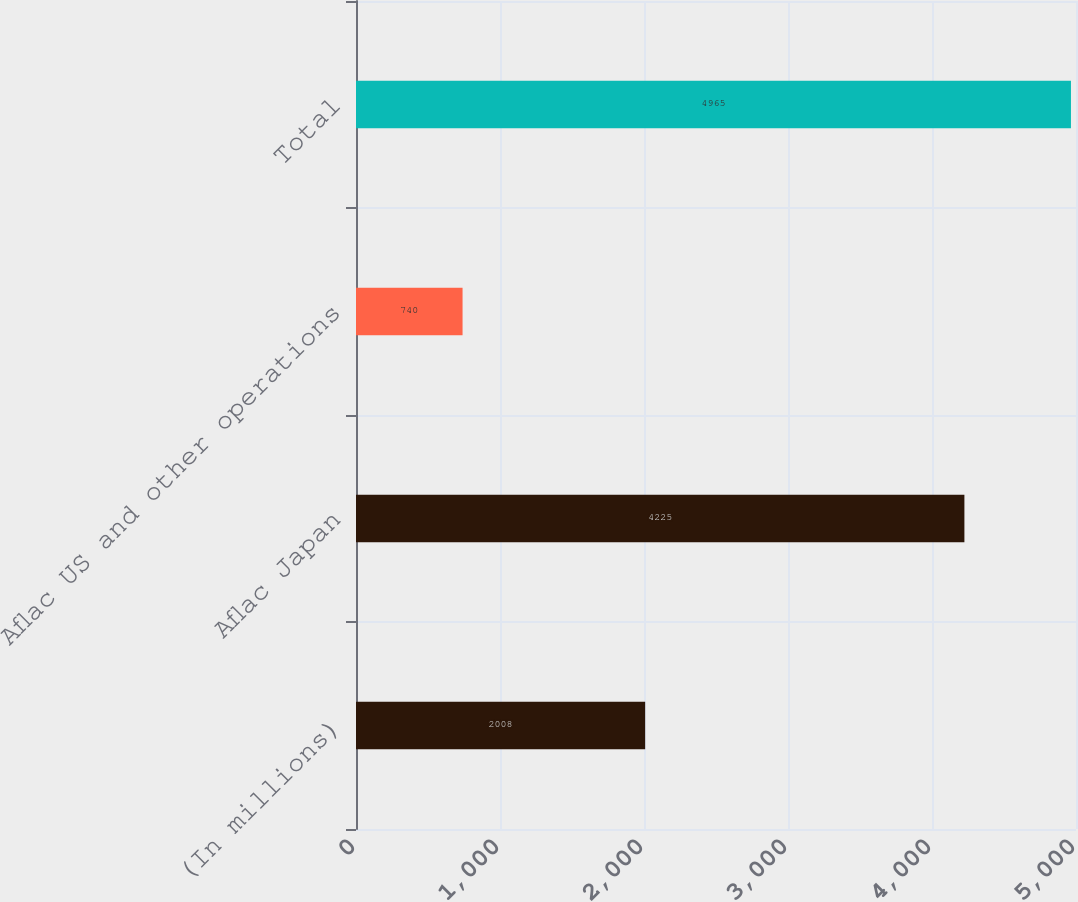Convert chart. <chart><loc_0><loc_0><loc_500><loc_500><bar_chart><fcel>(In millions)<fcel>Aflac Japan<fcel>Aflac US and other operations<fcel>Total<nl><fcel>2008<fcel>4225<fcel>740<fcel>4965<nl></chart> 